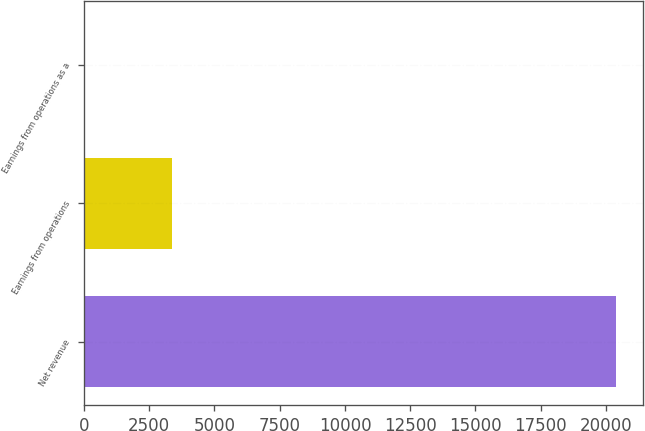Convert chart. <chart><loc_0><loc_0><loc_500><loc_500><bar_chart><fcel>Net revenue<fcel>Earnings from operations<fcel>Earnings from operations as a<nl><fcel>20399<fcel>3366<fcel>16.5<nl></chart> 